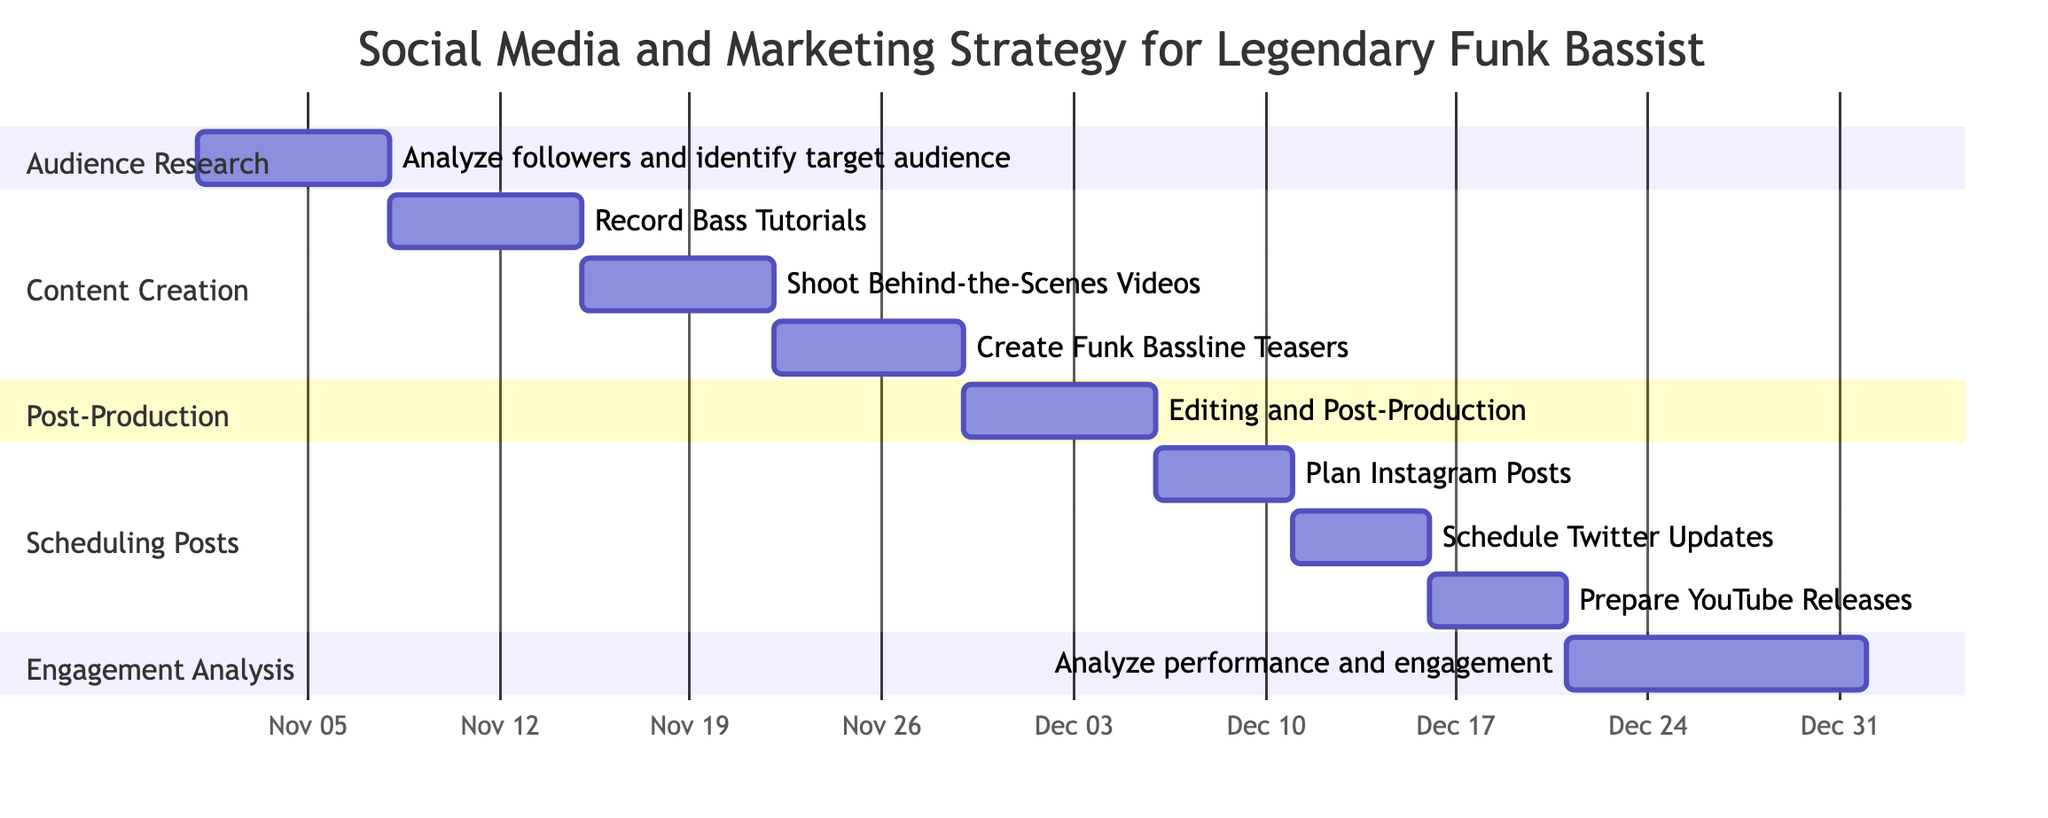What's the duration of the Audience Research task? The Audience Research task starts on November 1, 2023, and ends on November 7, 2023. This gives it a duration of 7 days.
Answer: 7 days How many subtasks are there in Content Creation? The Content Creation section includes three subtasks: Record Bass Tutorials, Shoot Behind-the-Scenes Videos, and Create Funk Bassline Teasers. Thus, there are a total of 3 subtasks.
Answer: 3 What is the end date of the Editing and Post-Production task? The Editing and Post-Production task starts on November 29, 2023, and ends on December 5, 2023. The end date is December 5, 2023.
Answer: December 5, 2023 Which task is scheduled just before the Engagement Analysis? The Engagement Analysis starts on December 21, 2023. The task scheduled just before it is Scheduling Posts, which ends on December 20, 2023.
Answer: Scheduling Posts What is the total duration of the personal engagement analysis phase? The Engagement Analysis task starts on December 21, 2023, and ends on December 31, 2023, resulting in a total duration of 11 days.
Answer: 11 days Which social media platform has posts scheduled last based on the chart? The last scheduled posts are for YouTube, which are Prepared for release from December 16 to December 20, 2023.
Answer: YouTube Which task has the longest duration among all tasks in the Gantt chart? The Audience Research task lasts 7 days, while other tasks like Engagement Analysis and Content Creation also have 7 days, but there aren’t any longer than 7 days overall. So, the longest duration is 7 days for multiple tasks.
Answer: 7 days What is the main focus of the Social Media and Marketing Strategy project? The project focuses on creating engaging content, scheduling posts on various platforms, and analyzing audience engagement with that content.
Answer: Content creation 